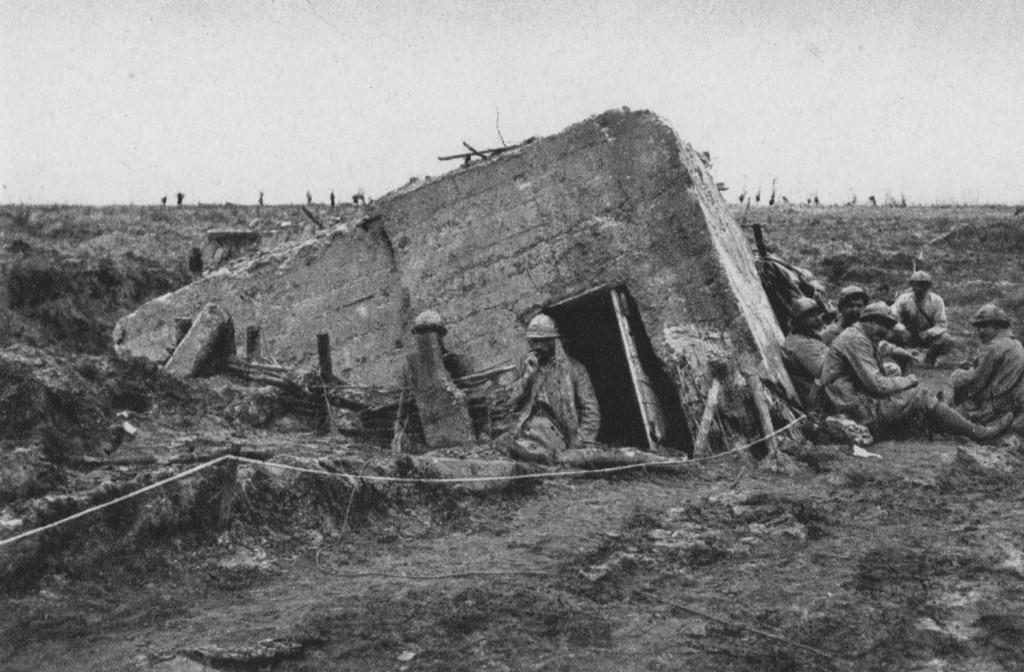What are the persons in the image doing? The persons in the image are sitting. What is located in front of the persons? There is a building in front of the persons. What can be seen at the back of the image? The sky is visible at the back of the image. What is the color scheme of the image? The image is in black and white. What type of beef is being served at the event in the image? There is no event or beef present in the image; it features persons sitting in front of a building with a black and white color scheme. 